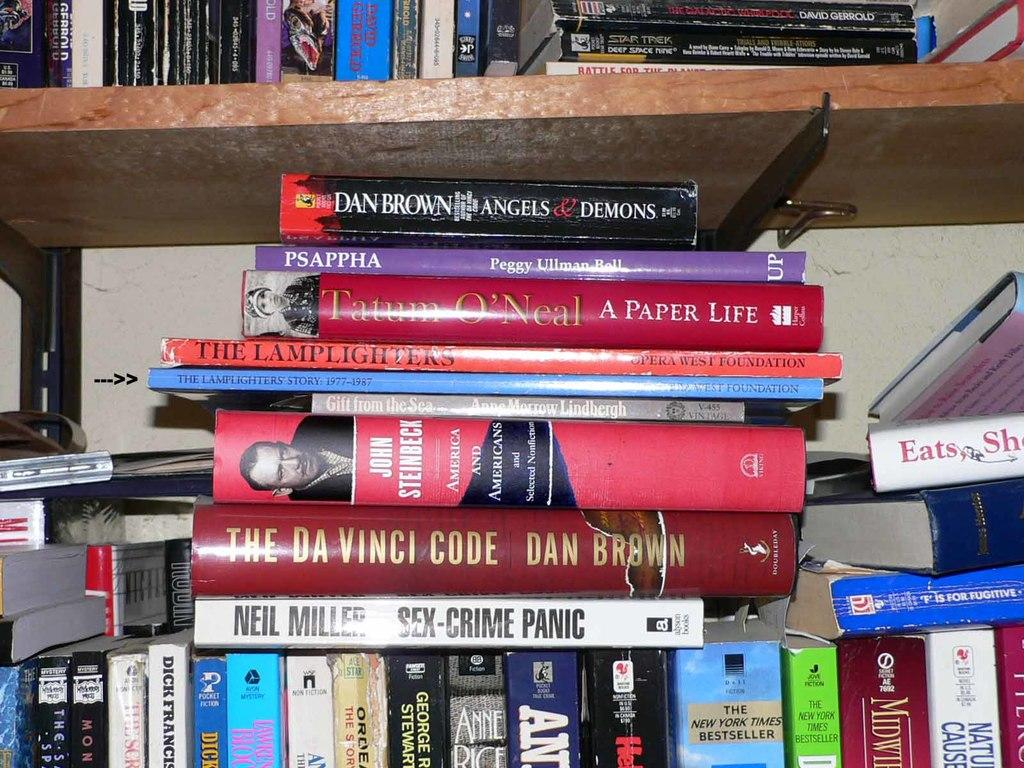<image>
Write a terse but informative summary of the picture. The Da Vinci Code by Dan Brown sits on a shelf above a Niel Miller book 